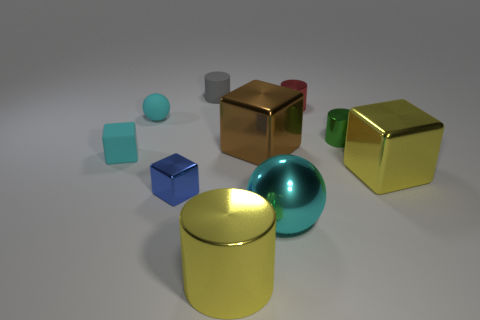What shape is the small cyan object that is made of the same material as the tiny cyan block?
Provide a short and direct response. Sphere. How many large cyan metallic balls are behind the block in front of the big yellow object right of the brown metal cube?
Offer a very short reply. 0. The tiny thing that is behind the tiny cyan sphere and to the right of the large cyan ball has what shape?
Offer a terse response. Cylinder. Are there fewer big yellow things that are behind the big cylinder than big purple objects?
Give a very brief answer. No. How many small objects are either rubber spheres or red cylinders?
Your answer should be very brief. 2. What is the size of the brown shiny cube?
Ensure brevity in your answer.  Large. Is there any other thing that is made of the same material as the tiny cyan sphere?
Make the answer very short. Yes. How many large metallic blocks are to the left of the small cyan rubber block?
Ensure brevity in your answer.  0. What size is the other matte thing that is the same shape as the big brown thing?
Your answer should be very brief. Small. There is a cyan thing that is both to the left of the gray thing and in front of the green cylinder; how big is it?
Make the answer very short. Small. 